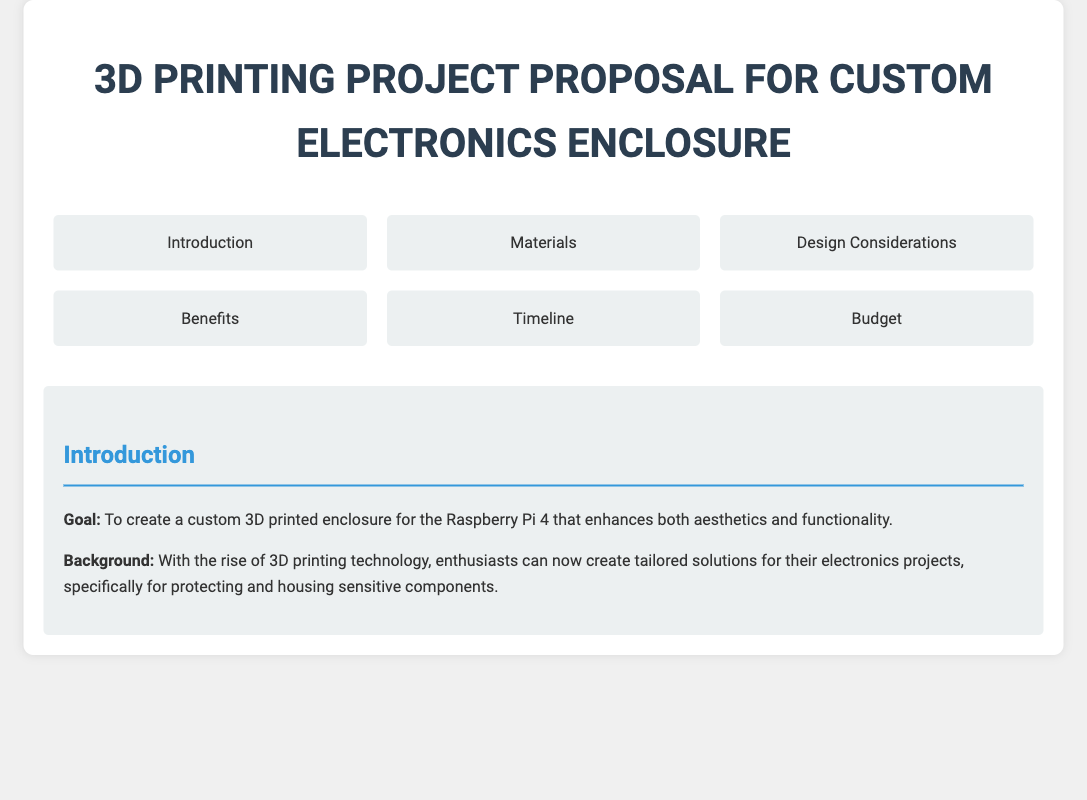what is the goal of the project? The goal of the project is to create a custom 3D printed enclosure for the Raspberry Pi 4 that enhances both aesthetics and functionality.
Answer: custom 3D printed enclosure for the Raspberry Pi 4 how long is the printing phase? The document outlines the timeline of the project, indicating that the printing phase lasts 2 days.
Answer: 2 days what are the three types of filament mentioned? The materials section lists the types of filament available for the project, which are PLA, ABS, and PETG.
Answer: PLA, ABS, PETG what is the total duration of the project? The timeline section summarizes the project duration, with all phases combined resulting in approximately 10 days.
Answer: Approximately 10 days which design software is used? The document specifies the design software used for the enclosure, which is Fusion 360.
Answer: Fusion 360 how many weeks does the design phase take? The timeline indicates that the design phase takes 1 week.
Answer: 1 week what is a key design consideration for ventilation? The design considerations list incorporates ventilation holes to prevent overheating as a key aspect.
Answer: Ventilation holes what is one of the benefits of using a custom enclosure? The benefits section highlights several advantages, such as providing protection against dust and accidental damage.
Answer: Protection against dust and accidental damage 